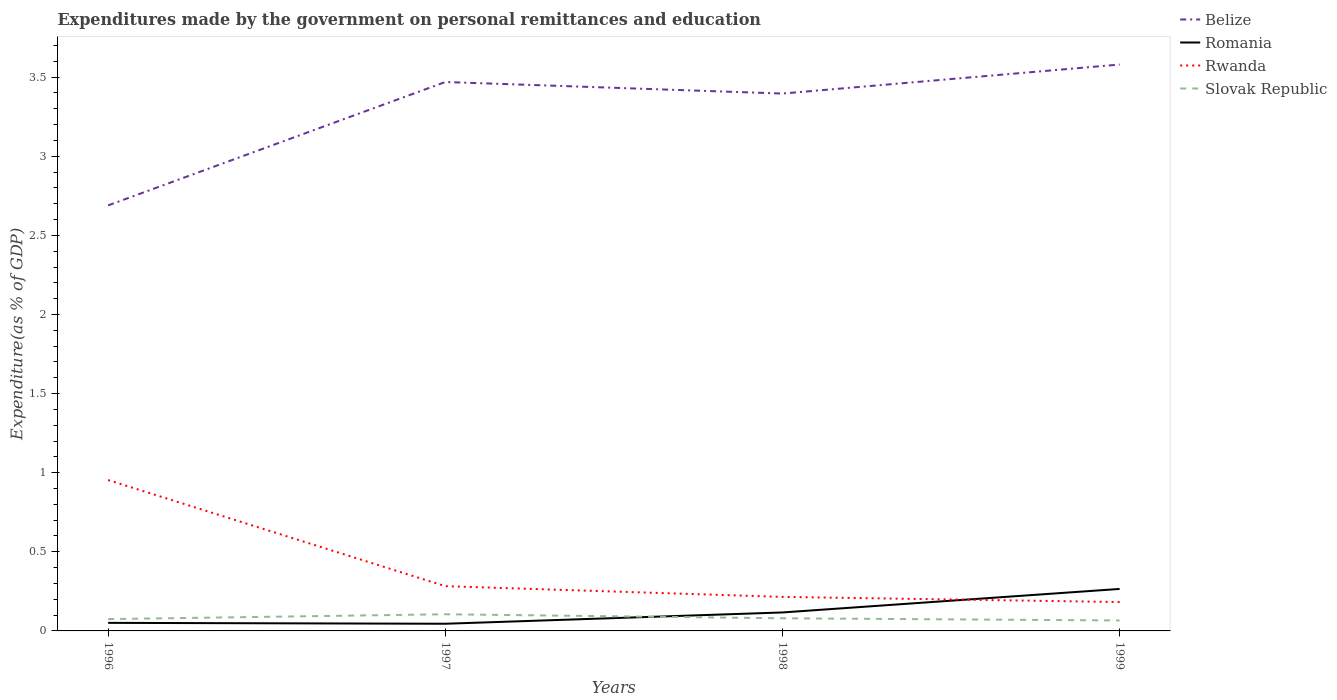How many different coloured lines are there?
Provide a succinct answer. 4. Across all years, what is the maximum expenditures made by the government on personal remittances and education in Slovak Republic?
Your response must be concise. 0.07. What is the total expenditures made by the government on personal remittances and education in Belize in the graph?
Provide a short and direct response. -0.18. What is the difference between the highest and the second highest expenditures made by the government on personal remittances and education in Romania?
Give a very brief answer. 0.22. Is the expenditures made by the government on personal remittances and education in Rwanda strictly greater than the expenditures made by the government on personal remittances and education in Belize over the years?
Give a very brief answer. Yes. How many lines are there?
Offer a terse response. 4. Are the values on the major ticks of Y-axis written in scientific E-notation?
Ensure brevity in your answer.  No. Does the graph contain grids?
Provide a succinct answer. No. How are the legend labels stacked?
Ensure brevity in your answer.  Vertical. What is the title of the graph?
Give a very brief answer. Expenditures made by the government on personal remittances and education. What is the label or title of the X-axis?
Provide a short and direct response. Years. What is the label or title of the Y-axis?
Offer a very short reply. Expenditure(as % of GDP). What is the Expenditure(as % of GDP) of Belize in 1996?
Your answer should be compact. 2.69. What is the Expenditure(as % of GDP) in Romania in 1996?
Offer a very short reply. 0.05. What is the Expenditure(as % of GDP) in Rwanda in 1996?
Provide a short and direct response. 0.95. What is the Expenditure(as % of GDP) of Slovak Republic in 1996?
Provide a succinct answer. 0.07. What is the Expenditure(as % of GDP) of Belize in 1997?
Your answer should be very brief. 3.47. What is the Expenditure(as % of GDP) in Romania in 1997?
Give a very brief answer. 0.05. What is the Expenditure(as % of GDP) in Rwanda in 1997?
Provide a short and direct response. 0.28. What is the Expenditure(as % of GDP) of Slovak Republic in 1997?
Give a very brief answer. 0.11. What is the Expenditure(as % of GDP) in Belize in 1998?
Give a very brief answer. 3.4. What is the Expenditure(as % of GDP) of Romania in 1998?
Keep it short and to the point. 0.12. What is the Expenditure(as % of GDP) in Rwanda in 1998?
Offer a very short reply. 0.22. What is the Expenditure(as % of GDP) in Slovak Republic in 1998?
Your answer should be compact. 0.08. What is the Expenditure(as % of GDP) in Belize in 1999?
Offer a very short reply. 3.58. What is the Expenditure(as % of GDP) in Romania in 1999?
Offer a very short reply. 0.27. What is the Expenditure(as % of GDP) in Rwanda in 1999?
Your response must be concise. 0.18. What is the Expenditure(as % of GDP) in Slovak Republic in 1999?
Offer a terse response. 0.07. Across all years, what is the maximum Expenditure(as % of GDP) in Belize?
Ensure brevity in your answer.  3.58. Across all years, what is the maximum Expenditure(as % of GDP) of Romania?
Offer a terse response. 0.27. Across all years, what is the maximum Expenditure(as % of GDP) of Rwanda?
Give a very brief answer. 0.95. Across all years, what is the maximum Expenditure(as % of GDP) of Slovak Republic?
Make the answer very short. 0.11. Across all years, what is the minimum Expenditure(as % of GDP) of Belize?
Offer a very short reply. 2.69. Across all years, what is the minimum Expenditure(as % of GDP) in Romania?
Make the answer very short. 0.05. Across all years, what is the minimum Expenditure(as % of GDP) in Rwanda?
Offer a terse response. 0.18. Across all years, what is the minimum Expenditure(as % of GDP) in Slovak Republic?
Make the answer very short. 0.07. What is the total Expenditure(as % of GDP) in Belize in the graph?
Ensure brevity in your answer.  13.13. What is the total Expenditure(as % of GDP) of Romania in the graph?
Offer a terse response. 0.48. What is the total Expenditure(as % of GDP) of Rwanda in the graph?
Offer a very short reply. 1.63. What is the total Expenditure(as % of GDP) in Slovak Republic in the graph?
Offer a terse response. 0.33. What is the difference between the Expenditure(as % of GDP) of Belize in 1996 and that in 1997?
Provide a succinct answer. -0.78. What is the difference between the Expenditure(as % of GDP) of Romania in 1996 and that in 1997?
Keep it short and to the point. 0.01. What is the difference between the Expenditure(as % of GDP) in Rwanda in 1996 and that in 1997?
Your answer should be compact. 0.67. What is the difference between the Expenditure(as % of GDP) in Slovak Republic in 1996 and that in 1997?
Your answer should be compact. -0.03. What is the difference between the Expenditure(as % of GDP) in Belize in 1996 and that in 1998?
Offer a terse response. -0.71. What is the difference between the Expenditure(as % of GDP) of Romania in 1996 and that in 1998?
Your answer should be very brief. -0.07. What is the difference between the Expenditure(as % of GDP) of Rwanda in 1996 and that in 1998?
Give a very brief answer. 0.74. What is the difference between the Expenditure(as % of GDP) of Slovak Republic in 1996 and that in 1998?
Offer a very short reply. -0.01. What is the difference between the Expenditure(as % of GDP) of Belize in 1996 and that in 1999?
Offer a terse response. -0.89. What is the difference between the Expenditure(as % of GDP) of Romania in 1996 and that in 1999?
Provide a succinct answer. -0.21. What is the difference between the Expenditure(as % of GDP) in Rwanda in 1996 and that in 1999?
Your answer should be very brief. 0.77. What is the difference between the Expenditure(as % of GDP) of Slovak Republic in 1996 and that in 1999?
Ensure brevity in your answer.  0.01. What is the difference between the Expenditure(as % of GDP) of Belize in 1997 and that in 1998?
Ensure brevity in your answer.  0.07. What is the difference between the Expenditure(as % of GDP) of Romania in 1997 and that in 1998?
Provide a succinct answer. -0.07. What is the difference between the Expenditure(as % of GDP) in Rwanda in 1997 and that in 1998?
Your answer should be very brief. 0.07. What is the difference between the Expenditure(as % of GDP) of Slovak Republic in 1997 and that in 1998?
Make the answer very short. 0.03. What is the difference between the Expenditure(as % of GDP) in Belize in 1997 and that in 1999?
Give a very brief answer. -0.11. What is the difference between the Expenditure(as % of GDP) of Romania in 1997 and that in 1999?
Provide a short and direct response. -0.22. What is the difference between the Expenditure(as % of GDP) of Rwanda in 1997 and that in 1999?
Your answer should be compact. 0.1. What is the difference between the Expenditure(as % of GDP) of Slovak Republic in 1997 and that in 1999?
Offer a terse response. 0.04. What is the difference between the Expenditure(as % of GDP) in Belize in 1998 and that in 1999?
Offer a terse response. -0.18. What is the difference between the Expenditure(as % of GDP) in Romania in 1998 and that in 1999?
Your response must be concise. -0.15. What is the difference between the Expenditure(as % of GDP) of Rwanda in 1998 and that in 1999?
Your answer should be very brief. 0.03. What is the difference between the Expenditure(as % of GDP) of Slovak Republic in 1998 and that in 1999?
Offer a terse response. 0.01. What is the difference between the Expenditure(as % of GDP) of Belize in 1996 and the Expenditure(as % of GDP) of Romania in 1997?
Your answer should be very brief. 2.64. What is the difference between the Expenditure(as % of GDP) in Belize in 1996 and the Expenditure(as % of GDP) in Rwanda in 1997?
Make the answer very short. 2.41. What is the difference between the Expenditure(as % of GDP) in Belize in 1996 and the Expenditure(as % of GDP) in Slovak Republic in 1997?
Provide a short and direct response. 2.58. What is the difference between the Expenditure(as % of GDP) of Romania in 1996 and the Expenditure(as % of GDP) of Rwanda in 1997?
Give a very brief answer. -0.23. What is the difference between the Expenditure(as % of GDP) in Romania in 1996 and the Expenditure(as % of GDP) in Slovak Republic in 1997?
Your response must be concise. -0.05. What is the difference between the Expenditure(as % of GDP) in Rwanda in 1996 and the Expenditure(as % of GDP) in Slovak Republic in 1997?
Offer a very short reply. 0.85. What is the difference between the Expenditure(as % of GDP) in Belize in 1996 and the Expenditure(as % of GDP) in Romania in 1998?
Offer a very short reply. 2.57. What is the difference between the Expenditure(as % of GDP) of Belize in 1996 and the Expenditure(as % of GDP) of Rwanda in 1998?
Ensure brevity in your answer.  2.47. What is the difference between the Expenditure(as % of GDP) in Belize in 1996 and the Expenditure(as % of GDP) in Slovak Republic in 1998?
Your answer should be compact. 2.61. What is the difference between the Expenditure(as % of GDP) of Romania in 1996 and the Expenditure(as % of GDP) of Rwanda in 1998?
Offer a terse response. -0.16. What is the difference between the Expenditure(as % of GDP) in Romania in 1996 and the Expenditure(as % of GDP) in Slovak Republic in 1998?
Ensure brevity in your answer.  -0.03. What is the difference between the Expenditure(as % of GDP) in Rwanda in 1996 and the Expenditure(as % of GDP) in Slovak Republic in 1998?
Your answer should be compact. 0.87. What is the difference between the Expenditure(as % of GDP) of Belize in 1996 and the Expenditure(as % of GDP) of Romania in 1999?
Your response must be concise. 2.42. What is the difference between the Expenditure(as % of GDP) of Belize in 1996 and the Expenditure(as % of GDP) of Rwanda in 1999?
Your answer should be very brief. 2.51. What is the difference between the Expenditure(as % of GDP) in Belize in 1996 and the Expenditure(as % of GDP) in Slovak Republic in 1999?
Offer a very short reply. 2.62. What is the difference between the Expenditure(as % of GDP) of Romania in 1996 and the Expenditure(as % of GDP) of Rwanda in 1999?
Your answer should be very brief. -0.13. What is the difference between the Expenditure(as % of GDP) of Romania in 1996 and the Expenditure(as % of GDP) of Slovak Republic in 1999?
Offer a terse response. -0.02. What is the difference between the Expenditure(as % of GDP) of Rwanda in 1996 and the Expenditure(as % of GDP) of Slovak Republic in 1999?
Offer a very short reply. 0.89. What is the difference between the Expenditure(as % of GDP) in Belize in 1997 and the Expenditure(as % of GDP) in Romania in 1998?
Make the answer very short. 3.35. What is the difference between the Expenditure(as % of GDP) of Belize in 1997 and the Expenditure(as % of GDP) of Rwanda in 1998?
Your answer should be very brief. 3.25. What is the difference between the Expenditure(as % of GDP) in Belize in 1997 and the Expenditure(as % of GDP) in Slovak Republic in 1998?
Keep it short and to the point. 3.39. What is the difference between the Expenditure(as % of GDP) of Romania in 1997 and the Expenditure(as % of GDP) of Rwanda in 1998?
Keep it short and to the point. -0.17. What is the difference between the Expenditure(as % of GDP) in Romania in 1997 and the Expenditure(as % of GDP) in Slovak Republic in 1998?
Keep it short and to the point. -0.03. What is the difference between the Expenditure(as % of GDP) of Rwanda in 1997 and the Expenditure(as % of GDP) of Slovak Republic in 1998?
Provide a short and direct response. 0.2. What is the difference between the Expenditure(as % of GDP) in Belize in 1997 and the Expenditure(as % of GDP) in Romania in 1999?
Offer a terse response. 3.2. What is the difference between the Expenditure(as % of GDP) of Belize in 1997 and the Expenditure(as % of GDP) of Rwanda in 1999?
Provide a succinct answer. 3.29. What is the difference between the Expenditure(as % of GDP) of Belize in 1997 and the Expenditure(as % of GDP) of Slovak Republic in 1999?
Your answer should be compact. 3.4. What is the difference between the Expenditure(as % of GDP) of Romania in 1997 and the Expenditure(as % of GDP) of Rwanda in 1999?
Your answer should be very brief. -0.14. What is the difference between the Expenditure(as % of GDP) in Romania in 1997 and the Expenditure(as % of GDP) in Slovak Republic in 1999?
Keep it short and to the point. -0.02. What is the difference between the Expenditure(as % of GDP) in Rwanda in 1997 and the Expenditure(as % of GDP) in Slovak Republic in 1999?
Your answer should be very brief. 0.22. What is the difference between the Expenditure(as % of GDP) in Belize in 1998 and the Expenditure(as % of GDP) in Romania in 1999?
Make the answer very short. 3.13. What is the difference between the Expenditure(as % of GDP) in Belize in 1998 and the Expenditure(as % of GDP) in Rwanda in 1999?
Offer a very short reply. 3.21. What is the difference between the Expenditure(as % of GDP) of Belize in 1998 and the Expenditure(as % of GDP) of Slovak Republic in 1999?
Ensure brevity in your answer.  3.33. What is the difference between the Expenditure(as % of GDP) of Romania in 1998 and the Expenditure(as % of GDP) of Rwanda in 1999?
Offer a very short reply. -0.07. What is the difference between the Expenditure(as % of GDP) in Romania in 1998 and the Expenditure(as % of GDP) in Slovak Republic in 1999?
Your answer should be very brief. 0.05. What is the difference between the Expenditure(as % of GDP) in Rwanda in 1998 and the Expenditure(as % of GDP) in Slovak Republic in 1999?
Offer a terse response. 0.15. What is the average Expenditure(as % of GDP) of Belize per year?
Your answer should be very brief. 3.28. What is the average Expenditure(as % of GDP) in Romania per year?
Your answer should be compact. 0.12. What is the average Expenditure(as % of GDP) in Rwanda per year?
Provide a succinct answer. 0.41. What is the average Expenditure(as % of GDP) in Slovak Republic per year?
Your answer should be very brief. 0.08. In the year 1996, what is the difference between the Expenditure(as % of GDP) of Belize and Expenditure(as % of GDP) of Romania?
Give a very brief answer. 2.64. In the year 1996, what is the difference between the Expenditure(as % of GDP) in Belize and Expenditure(as % of GDP) in Rwanda?
Your answer should be compact. 1.74. In the year 1996, what is the difference between the Expenditure(as % of GDP) in Belize and Expenditure(as % of GDP) in Slovak Republic?
Your response must be concise. 2.61. In the year 1996, what is the difference between the Expenditure(as % of GDP) in Romania and Expenditure(as % of GDP) in Rwanda?
Your answer should be very brief. -0.9. In the year 1996, what is the difference between the Expenditure(as % of GDP) of Romania and Expenditure(as % of GDP) of Slovak Republic?
Offer a terse response. -0.02. In the year 1996, what is the difference between the Expenditure(as % of GDP) in Rwanda and Expenditure(as % of GDP) in Slovak Republic?
Provide a succinct answer. 0.88. In the year 1997, what is the difference between the Expenditure(as % of GDP) of Belize and Expenditure(as % of GDP) of Romania?
Make the answer very short. 3.42. In the year 1997, what is the difference between the Expenditure(as % of GDP) of Belize and Expenditure(as % of GDP) of Rwanda?
Offer a terse response. 3.19. In the year 1997, what is the difference between the Expenditure(as % of GDP) of Belize and Expenditure(as % of GDP) of Slovak Republic?
Ensure brevity in your answer.  3.36. In the year 1997, what is the difference between the Expenditure(as % of GDP) of Romania and Expenditure(as % of GDP) of Rwanda?
Your answer should be compact. -0.24. In the year 1997, what is the difference between the Expenditure(as % of GDP) in Romania and Expenditure(as % of GDP) in Slovak Republic?
Keep it short and to the point. -0.06. In the year 1997, what is the difference between the Expenditure(as % of GDP) of Rwanda and Expenditure(as % of GDP) of Slovak Republic?
Offer a terse response. 0.18. In the year 1998, what is the difference between the Expenditure(as % of GDP) in Belize and Expenditure(as % of GDP) in Romania?
Provide a succinct answer. 3.28. In the year 1998, what is the difference between the Expenditure(as % of GDP) in Belize and Expenditure(as % of GDP) in Rwanda?
Offer a very short reply. 3.18. In the year 1998, what is the difference between the Expenditure(as % of GDP) in Belize and Expenditure(as % of GDP) in Slovak Republic?
Ensure brevity in your answer.  3.32. In the year 1998, what is the difference between the Expenditure(as % of GDP) of Romania and Expenditure(as % of GDP) of Rwanda?
Make the answer very short. -0.1. In the year 1998, what is the difference between the Expenditure(as % of GDP) in Romania and Expenditure(as % of GDP) in Slovak Republic?
Give a very brief answer. 0.04. In the year 1998, what is the difference between the Expenditure(as % of GDP) in Rwanda and Expenditure(as % of GDP) in Slovak Republic?
Your answer should be very brief. 0.14. In the year 1999, what is the difference between the Expenditure(as % of GDP) of Belize and Expenditure(as % of GDP) of Romania?
Offer a very short reply. 3.31. In the year 1999, what is the difference between the Expenditure(as % of GDP) of Belize and Expenditure(as % of GDP) of Rwanda?
Provide a succinct answer. 3.4. In the year 1999, what is the difference between the Expenditure(as % of GDP) in Belize and Expenditure(as % of GDP) in Slovak Republic?
Provide a succinct answer. 3.51. In the year 1999, what is the difference between the Expenditure(as % of GDP) in Romania and Expenditure(as % of GDP) in Rwanda?
Your response must be concise. 0.08. In the year 1999, what is the difference between the Expenditure(as % of GDP) of Romania and Expenditure(as % of GDP) of Slovak Republic?
Ensure brevity in your answer.  0.2. In the year 1999, what is the difference between the Expenditure(as % of GDP) of Rwanda and Expenditure(as % of GDP) of Slovak Republic?
Keep it short and to the point. 0.12. What is the ratio of the Expenditure(as % of GDP) of Belize in 1996 to that in 1997?
Your response must be concise. 0.78. What is the ratio of the Expenditure(as % of GDP) of Romania in 1996 to that in 1997?
Offer a terse response. 1.12. What is the ratio of the Expenditure(as % of GDP) in Rwanda in 1996 to that in 1997?
Ensure brevity in your answer.  3.37. What is the ratio of the Expenditure(as % of GDP) of Slovak Republic in 1996 to that in 1997?
Make the answer very short. 0.71. What is the ratio of the Expenditure(as % of GDP) of Belize in 1996 to that in 1998?
Your answer should be very brief. 0.79. What is the ratio of the Expenditure(as % of GDP) in Romania in 1996 to that in 1998?
Your answer should be compact. 0.44. What is the ratio of the Expenditure(as % of GDP) in Rwanda in 1996 to that in 1998?
Provide a succinct answer. 4.43. What is the ratio of the Expenditure(as % of GDP) in Slovak Republic in 1996 to that in 1998?
Provide a short and direct response. 0.94. What is the ratio of the Expenditure(as % of GDP) of Belize in 1996 to that in 1999?
Your response must be concise. 0.75. What is the ratio of the Expenditure(as % of GDP) in Romania in 1996 to that in 1999?
Offer a very short reply. 0.19. What is the ratio of the Expenditure(as % of GDP) in Rwanda in 1996 to that in 1999?
Keep it short and to the point. 5.22. What is the ratio of the Expenditure(as % of GDP) of Slovak Republic in 1996 to that in 1999?
Provide a short and direct response. 1.13. What is the ratio of the Expenditure(as % of GDP) in Belize in 1997 to that in 1998?
Provide a succinct answer. 1.02. What is the ratio of the Expenditure(as % of GDP) in Romania in 1997 to that in 1998?
Keep it short and to the point. 0.39. What is the ratio of the Expenditure(as % of GDP) of Rwanda in 1997 to that in 1998?
Give a very brief answer. 1.32. What is the ratio of the Expenditure(as % of GDP) of Slovak Republic in 1997 to that in 1998?
Your response must be concise. 1.32. What is the ratio of the Expenditure(as % of GDP) of Belize in 1997 to that in 1999?
Your answer should be very brief. 0.97. What is the ratio of the Expenditure(as % of GDP) of Romania in 1997 to that in 1999?
Provide a short and direct response. 0.17. What is the ratio of the Expenditure(as % of GDP) of Rwanda in 1997 to that in 1999?
Provide a short and direct response. 1.55. What is the ratio of the Expenditure(as % of GDP) in Slovak Republic in 1997 to that in 1999?
Keep it short and to the point. 1.59. What is the ratio of the Expenditure(as % of GDP) in Belize in 1998 to that in 1999?
Your answer should be very brief. 0.95. What is the ratio of the Expenditure(as % of GDP) of Romania in 1998 to that in 1999?
Provide a succinct answer. 0.44. What is the ratio of the Expenditure(as % of GDP) in Rwanda in 1998 to that in 1999?
Provide a succinct answer. 1.18. What is the ratio of the Expenditure(as % of GDP) in Slovak Republic in 1998 to that in 1999?
Keep it short and to the point. 1.21. What is the difference between the highest and the second highest Expenditure(as % of GDP) of Belize?
Provide a short and direct response. 0.11. What is the difference between the highest and the second highest Expenditure(as % of GDP) of Romania?
Make the answer very short. 0.15. What is the difference between the highest and the second highest Expenditure(as % of GDP) in Rwanda?
Provide a succinct answer. 0.67. What is the difference between the highest and the second highest Expenditure(as % of GDP) in Slovak Republic?
Your answer should be compact. 0.03. What is the difference between the highest and the lowest Expenditure(as % of GDP) of Belize?
Offer a very short reply. 0.89. What is the difference between the highest and the lowest Expenditure(as % of GDP) of Romania?
Provide a succinct answer. 0.22. What is the difference between the highest and the lowest Expenditure(as % of GDP) of Rwanda?
Keep it short and to the point. 0.77. What is the difference between the highest and the lowest Expenditure(as % of GDP) of Slovak Republic?
Provide a short and direct response. 0.04. 